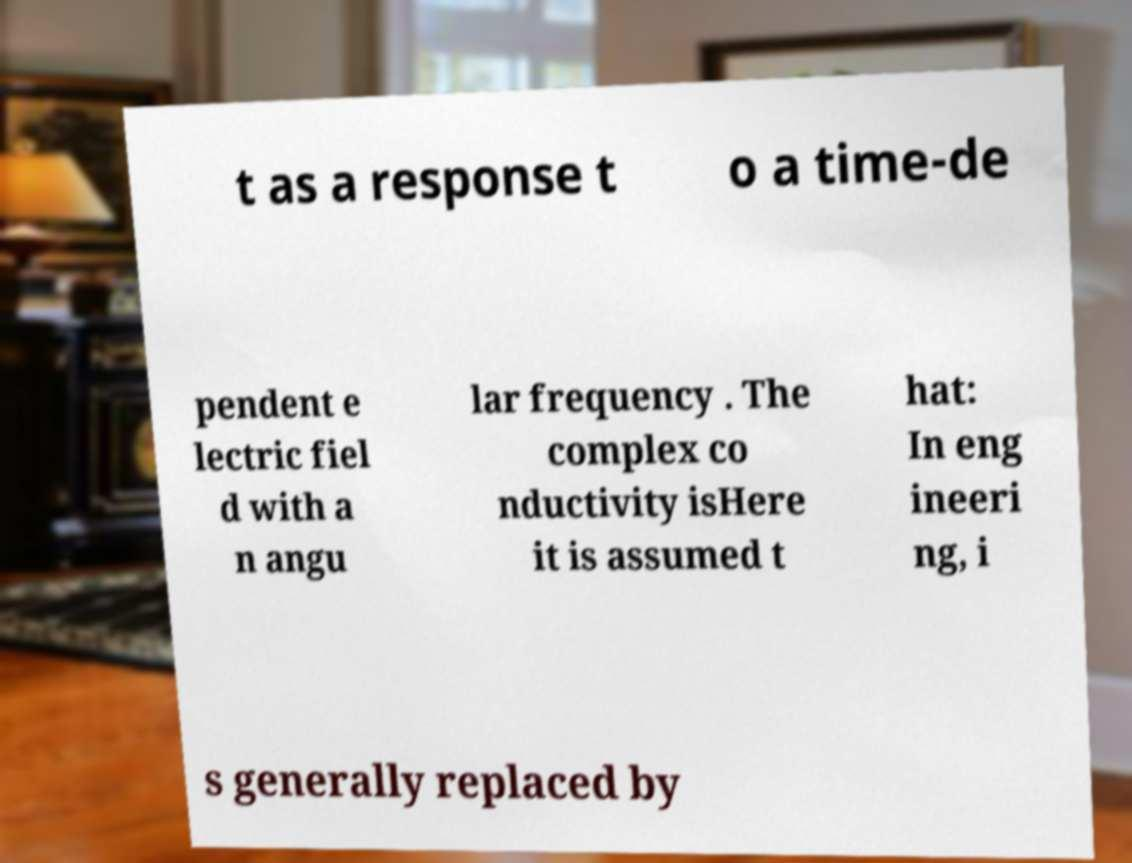Please identify and transcribe the text found in this image. t as a response t o a time-de pendent e lectric fiel d with a n angu lar frequency . The complex co nductivity isHere it is assumed t hat: In eng ineeri ng, i s generally replaced by 